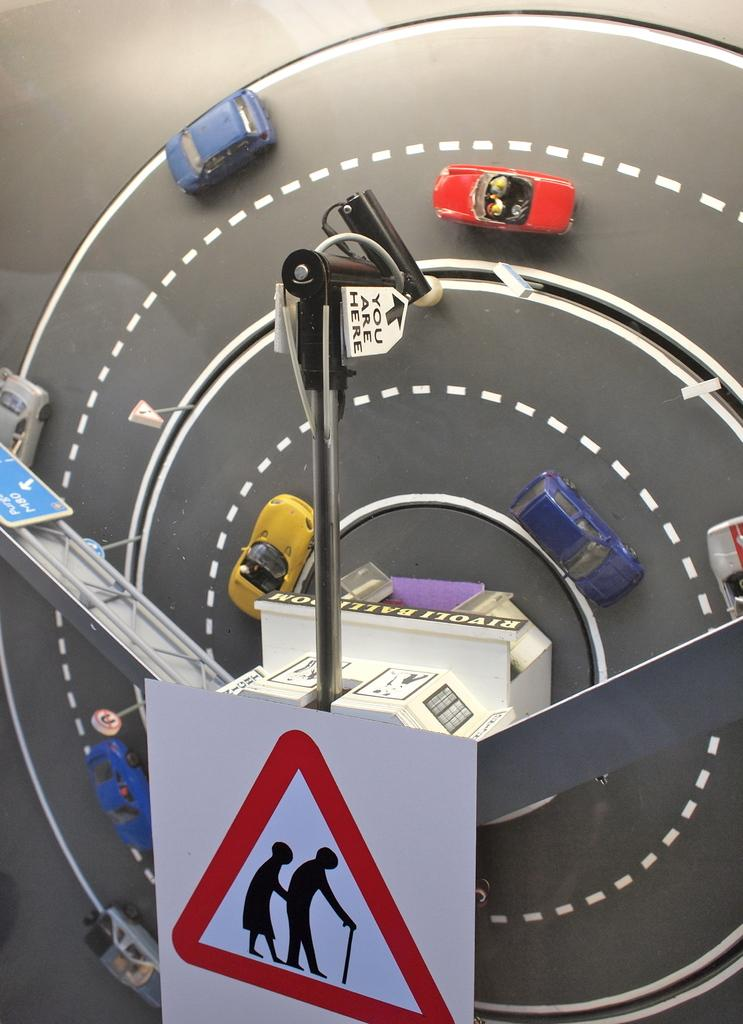What type of objects are in the image? There are miniature vehicles in the image. Where are the vehicles located? The vehicles are on a road in the image. What can be said about the appearance of the vehicles? The vehicles are colorful. What other objects can be seen in the image? There is a pole and a board in the image. What day of the week is it in the image? The day of the week is not mentioned or depicted in the image. Can you tell me how many grandmothers are in the image? There are no grandmothers present in the image. 